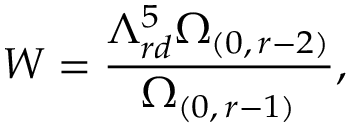<formula> <loc_0><loc_0><loc_500><loc_500>W = \frac { \Lambda _ { r d } ^ { 5 } \Omega _ { ( 0 , \, r - 2 ) } } { \Omega _ { ( 0 , \, r - 1 ) } } ,</formula> 